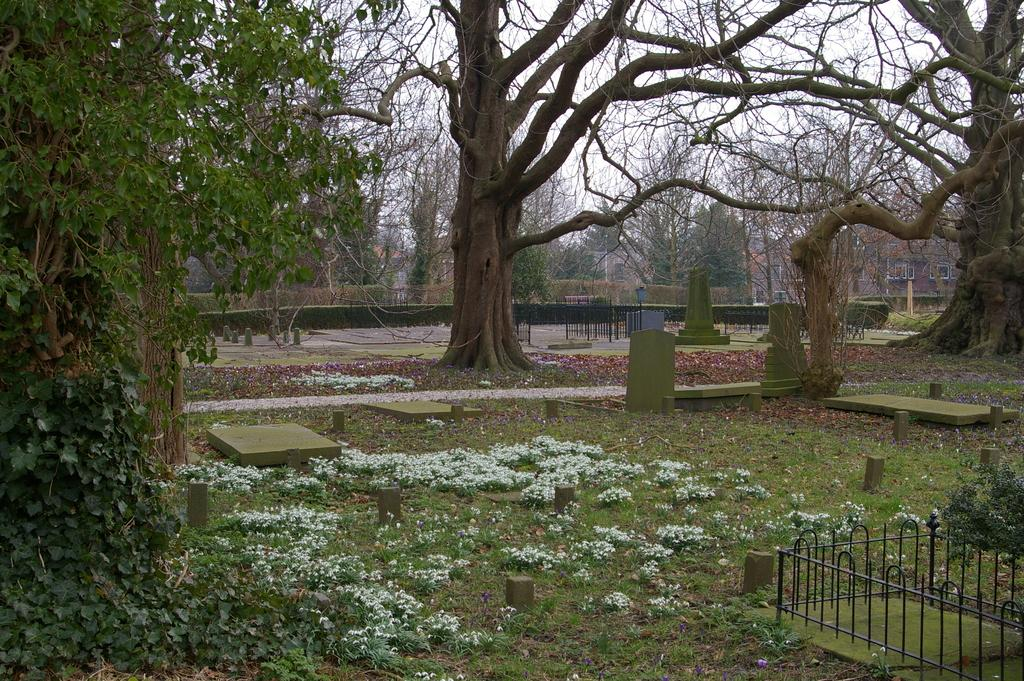What type of vegetation can be seen in the image? There is grass, trees, and shrubs in the image. What type of structure is present in the image? There is a building in the image. What type of boundary is visible in the image? There is a fence in the image. What type of markers are present in the image? There are memorial stones in the image. What is visible in the background of the image? The sky is visible in the background of the image. What type of hair can be seen on the fence in the image? There is no hair present on the fence in the image. How does the brake system work on the trees in the image? There is no brake system present on the trees in the image. 